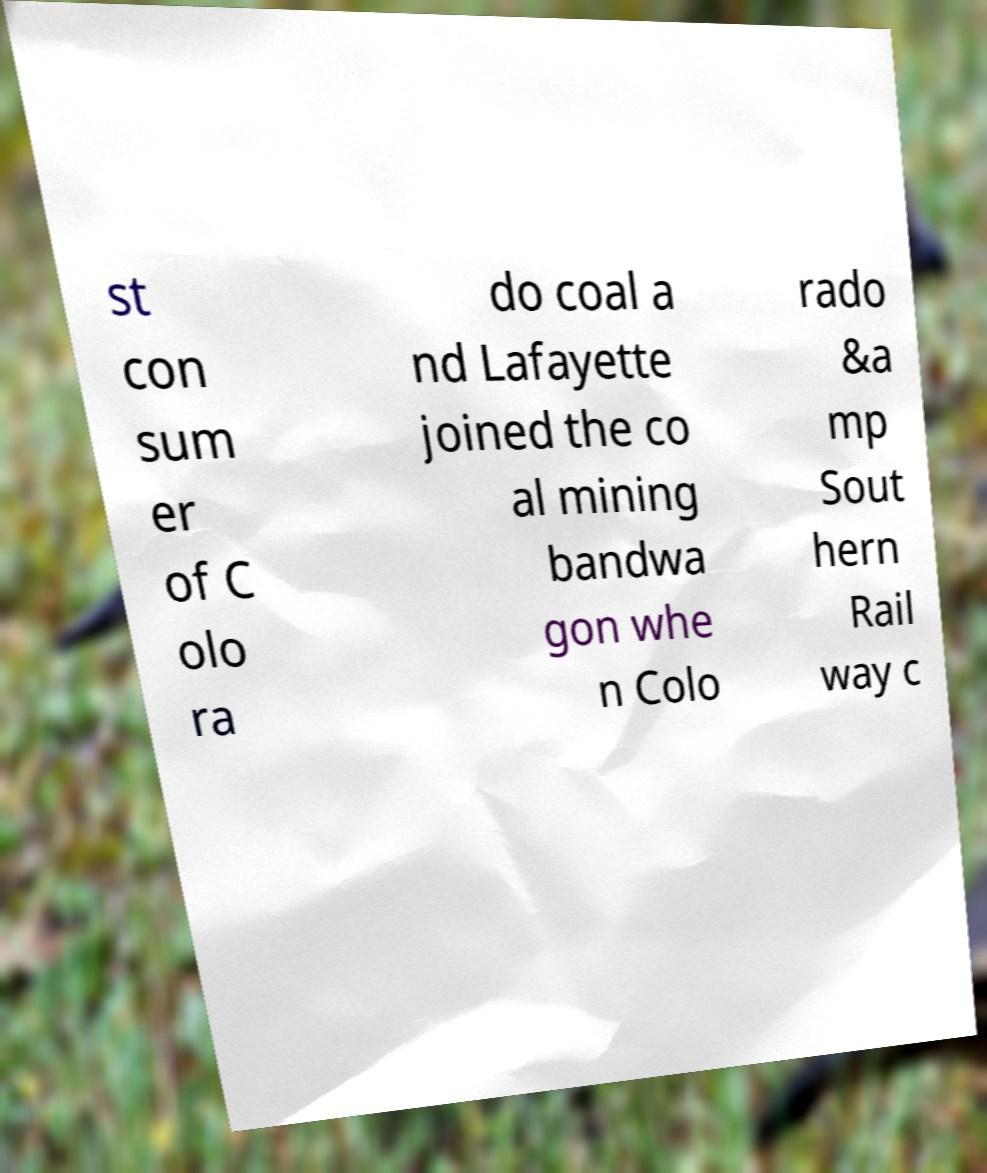Can you accurately transcribe the text from the provided image for me? st con sum er of C olo ra do coal a nd Lafayette joined the co al mining bandwa gon whe n Colo rado &a mp Sout hern Rail way c 